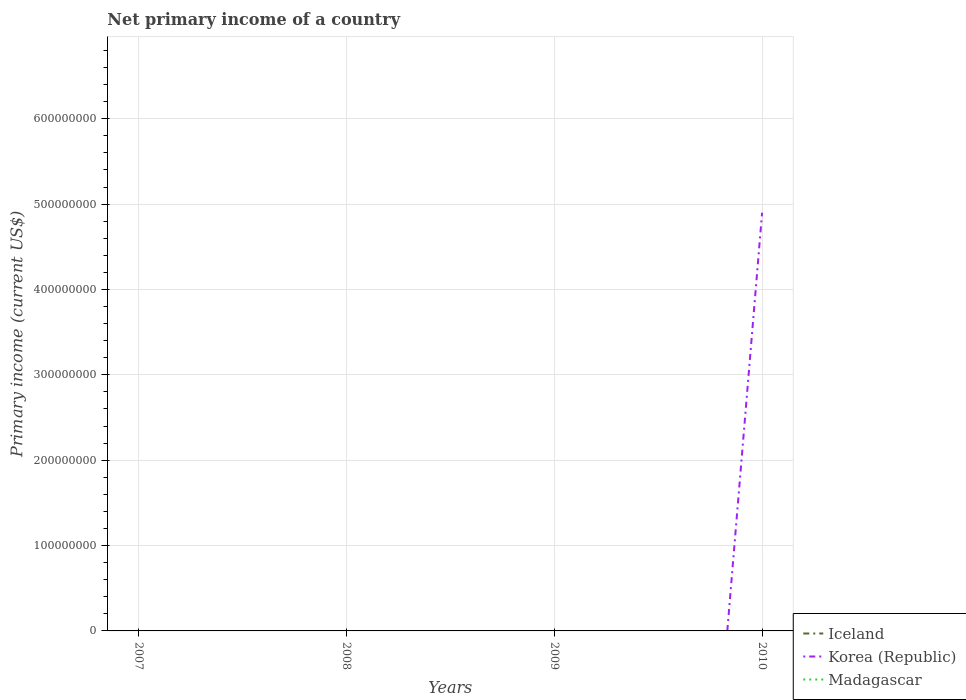Does the line corresponding to Iceland intersect with the line corresponding to Madagascar?
Offer a terse response. No. Is the number of lines equal to the number of legend labels?
Your answer should be very brief. No. What is the difference between the highest and the second highest primary income in Korea (Republic)?
Your response must be concise. 4.90e+08. What is the difference between the highest and the lowest primary income in Iceland?
Offer a terse response. 0. How many years are there in the graph?
Your answer should be very brief. 4. Are the values on the major ticks of Y-axis written in scientific E-notation?
Your response must be concise. No. Where does the legend appear in the graph?
Your response must be concise. Bottom right. What is the title of the graph?
Your answer should be compact. Net primary income of a country. Does "Belarus" appear as one of the legend labels in the graph?
Offer a terse response. No. What is the label or title of the X-axis?
Your response must be concise. Years. What is the label or title of the Y-axis?
Your answer should be compact. Primary income (current US$). What is the Primary income (current US$) of Madagascar in 2007?
Ensure brevity in your answer.  0. What is the Primary income (current US$) of Iceland in 2008?
Offer a terse response. 0. What is the Primary income (current US$) of Korea (Republic) in 2008?
Provide a succinct answer. 0. What is the Primary income (current US$) of Korea (Republic) in 2009?
Offer a very short reply. 0. What is the Primary income (current US$) of Madagascar in 2009?
Ensure brevity in your answer.  0. What is the Primary income (current US$) of Iceland in 2010?
Make the answer very short. 0. What is the Primary income (current US$) of Korea (Republic) in 2010?
Your answer should be very brief. 4.90e+08. Across all years, what is the maximum Primary income (current US$) in Korea (Republic)?
Make the answer very short. 4.90e+08. What is the total Primary income (current US$) in Korea (Republic) in the graph?
Offer a terse response. 4.90e+08. What is the average Primary income (current US$) in Korea (Republic) per year?
Ensure brevity in your answer.  1.22e+08. What is the difference between the highest and the lowest Primary income (current US$) in Korea (Republic)?
Your response must be concise. 4.90e+08. 